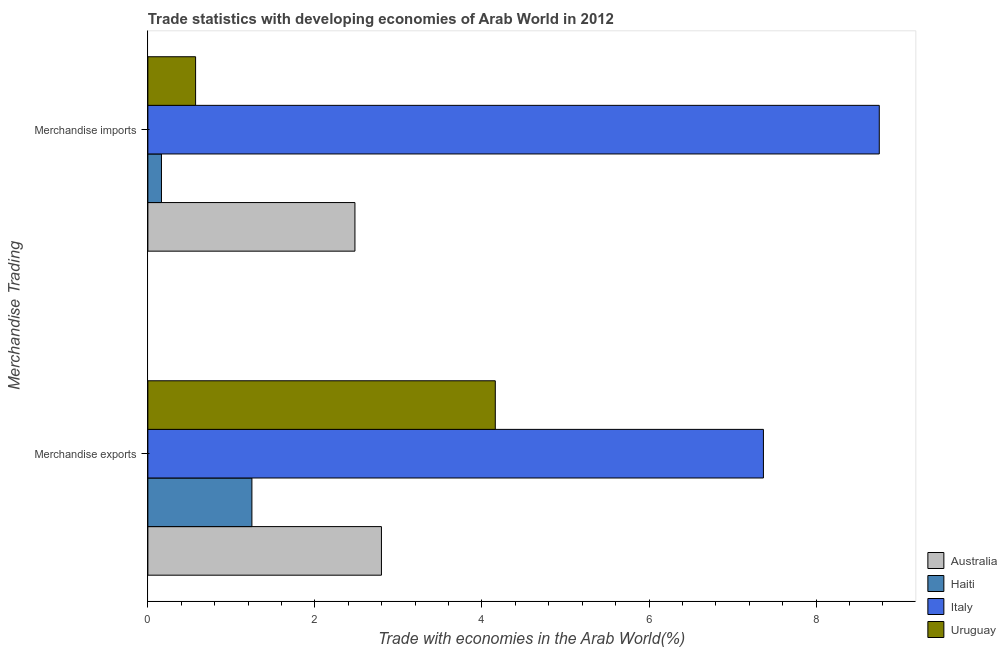How many groups of bars are there?
Keep it short and to the point. 2. Are the number of bars per tick equal to the number of legend labels?
Offer a very short reply. Yes. Are the number of bars on each tick of the Y-axis equal?
Offer a terse response. Yes. How many bars are there on the 1st tick from the bottom?
Provide a short and direct response. 4. What is the label of the 2nd group of bars from the top?
Your answer should be very brief. Merchandise exports. What is the merchandise imports in Italy?
Give a very brief answer. 8.76. Across all countries, what is the maximum merchandise exports?
Ensure brevity in your answer.  7.37. Across all countries, what is the minimum merchandise exports?
Offer a terse response. 1.25. In which country was the merchandise imports maximum?
Your response must be concise. Italy. In which country was the merchandise imports minimum?
Your response must be concise. Haiti. What is the total merchandise exports in the graph?
Offer a terse response. 15.57. What is the difference between the merchandise imports in Australia and that in Uruguay?
Provide a succinct answer. 1.91. What is the difference between the merchandise imports in Uruguay and the merchandise exports in Haiti?
Your answer should be very brief. -0.67. What is the average merchandise exports per country?
Provide a short and direct response. 3.89. What is the difference between the merchandise imports and merchandise exports in Uruguay?
Provide a succinct answer. -3.59. In how many countries, is the merchandise exports greater than 4 %?
Give a very brief answer. 2. What is the ratio of the merchandise imports in Uruguay to that in Italy?
Your answer should be very brief. 0.07. Are all the bars in the graph horizontal?
Offer a terse response. Yes. What is the difference between two consecutive major ticks on the X-axis?
Offer a terse response. 2. Does the graph contain grids?
Provide a succinct answer. No. Where does the legend appear in the graph?
Provide a short and direct response. Bottom right. How are the legend labels stacked?
Give a very brief answer. Vertical. What is the title of the graph?
Your response must be concise. Trade statistics with developing economies of Arab World in 2012. What is the label or title of the X-axis?
Your response must be concise. Trade with economies in the Arab World(%). What is the label or title of the Y-axis?
Your answer should be very brief. Merchandise Trading. What is the Trade with economies in the Arab World(%) in Australia in Merchandise exports?
Your answer should be compact. 2.8. What is the Trade with economies in the Arab World(%) in Haiti in Merchandise exports?
Offer a terse response. 1.25. What is the Trade with economies in the Arab World(%) of Italy in Merchandise exports?
Make the answer very short. 7.37. What is the Trade with economies in the Arab World(%) in Uruguay in Merchandise exports?
Offer a terse response. 4.16. What is the Trade with economies in the Arab World(%) in Australia in Merchandise imports?
Your answer should be compact. 2.48. What is the Trade with economies in the Arab World(%) in Haiti in Merchandise imports?
Offer a very short reply. 0.16. What is the Trade with economies in the Arab World(%) in Italy in Merchandise imports?
Offer a terse response. 8.76. What is the Trade with economies in the Arab World(%) of Uruguay in Merchandise imports?
Your answer should be very brief. 0.57. Across all Merchandise Trading, what is the maximum Trade with economies in the Arab World(%) of Australia?
Ensure brevity in your answer.  2.8. Across all Merchandise Trading, what is the maximum Trade with economies in the Arab World(%) of Haiti?
Make the answer very short. 1.25. Across all Merchandise Trading, what is the maximum Trade with economies in the Arab World(%) in Italy?
Your answer should be very brief. 8.76. Across all Merchandise Trading, what is the maximum Trade with economies in the Arab World(%) in Uruguay?
Your response must be concise. 4.16. Across all Merchandise Trading, what is the minimum Trade with economies in the Arab World(%) in Australia?
Your answer should be compact. 2.48. Across all Merchandise Trading, what is the minimum Trade with economies in the Arab World(%) of Haiti?
Offer a terse response. 0.16. Across all Merchandise Trading, what is the minimum Trade with economies in the Arab World(%) of Italy?
Offer a terse response. 7.37. Across all Merchandise Trading, what is the minimum Trade with economies in the Arab World(%) of Uruguay?
Your answer should be very brief. 0.57. What is the total Trade with economies in the Arab World(%) in Australia in the graph?
Ensure brevity in your answer.  5.28. What is the total Trade with economies in the Arab World(%) in Haiti in the graph?
Your response must be concise. 1.41. What is the total Trade with economies in the Arab World(%) in Italy in the graph?
Provide a succinct answer. 16.13. What is the total Trade with economies in the Arab World(%) in Uruguay in the graph?
Give a very brief answer. 4.73. What is the difference between the Trade with economies in the Arab World(%) of Australia in Merchandise exports and that in Merchandise imports?
Provide a succinct answer. 0.32. What is the difference between the Trade with economies in the Arab World(%) in Haiti in Merchandise exports and that in Merchandise imports?
Make the answer very short. 1.08. What is the difference between the Trade with economies in the Arab World(%) in Italy in Merchandise exports and that in Merchandise imports?
Ensure brevity in your answer.  -1.39. What is the difference between the Trade with economies in the Arab World(%) in Uruguay in Merchandise exports and that in Merchandise imports?
Your response must be concise. 3.59. What is the difference between the Trade with economies in the Arab World(%) of Australia in Merchandise exports and the Trade with economies in the Arab World(%) of Haiti in Merchandise imports?
Provide a short and direct response. 2.63. What is the difference between the Trade with economies in the Arab World(%) in Australia in Merchandise exports and the Trade with economies in the Arab World(%) in Italy in Merchandise imports?
Offer a terse response. -5.96. What is the difference between the Trade with economies in the Arab World(%) in Australia in Merchandise exports and the Trade with economies in the Arab World(%) in Uruguay in Merchandise imports?
Your answer should be very brief. 2.22. What is the difference between the Trade with economies in the Arab World(%) in Haiti in Merchandise exports and the Trade with economies in the Arab World(%) in Italy in Merchandise imports?
Your answer should be compact. -7.51. What is the difference between the Trade with economies in the Arab World(%) of Haiti in Merchandise exports and the Trade with economies in the Arab World(%) of Uruguay in Merchandise imports?
Provide a short and direct response. 0.67. What is the difference between the Trade with economies in the Arab World(%) of Italy in Merchandise exports and the Trade with economies in the Arab World(%) of Uruguay in Merchandise imports?
Ensure brevity in your answer.  6.8. What is the average Trade with economies in the Arab World(%) in Australia per Merchandise Trading?
Provide a succinct answer. 2.64. What is the average Trade with economies in the Arab World(%) in Haiti per Merchandise Trading?
Provide a short and direct response. 0.7. What is the average Trade with economies in the Arab World(%) in Italy per Merchandise Trading?
Ensure brevity in your answer.  8.06. What is the average Trade with economies in the Arab World(%) of Uruguay per Merchandise Trading?
Give a very brief answer. 2.37. What is the difference between the Trade with economies in the Arab World(%) in Australia and Trade with economies in the Arab World(%) in Haiti in Merchandise exports?
Your answer should be compact. 1.55. What is the difference between the Trade with economies in the Arab World(%) in Australia and Trade with economies in the Arab World(%) in Italy in Merchandise exports?
Give a very brief answer. -4.57. What is the difference between the Trade with economies in the Arab World(%) of Australia and Trade with economies in the Arab World(%) of Uruguay in Merchandise exports?
Provide a succinct answer. -1.36. What is the difference between the Trade with economies in the Arab World(%) in Haiti and Trade with economies in the Arab World(%) in Italy in Merchandise exports?
Keep it short and to the point. -6.12. What is the difference between the Trade with economies in the Arab World(%) in Haiti and Trade with economies in the Arab World(%) in Uruguay in Merchandise exports?
Your answer should be very brief. -2.91. What is the difference between the Trade with economies in the Arab World(%) in Italy and Trade with economies in the Arab World(%) in Uruguay in Merchandise exports?
Offer a terse response. 3.21. What is the difference between the Trade with economies in the Arab World(%) of Australia and Trade with economies in the Arab World(%) of Haiti in Merchandise imports?
Offer a terse response. 2.32. What is the difference between the Trade with economies in the Arab World(%) of Australia and Trade with economies in the Arab World(%) of Italy in Merchandise imports?
Make the answer very short. -6.28. What is the difference between the Trade with economies in the Arab World(%) of Australia and Trade with economies in the Arab World(%) of Uruguay in Merchandise imports?
Your answer should be compact. 1.91. What is the difference between the Trade with economies in the Arab World(%) of Haiti and Trade with economies in the Arab World(%) of Italy in Merchandise imports?
Offer a very short reply. -8.59. What is the difference between the Trade with economies in the Arab World(%) in Haiti and Trade with economies in the Arab World(%) in Uruguay in Merchandise imports?
Your answer should be very brief. -0.41. What is the difference between the Trade with economies in the Arab World(%) in Italy and Trade with economies in the Arab World(%) in Uruguay in Merchandise imports?
Provide a succinct answer. 8.19. What is the ratio of the Trade with economies in the Arab World(%) of Australia in Merchandise exports to that in Merchandise imports?
Your answer should be compact. 1.13. What is the ratio of the Trade with economies in the Arab World(%) in Haiti in Merchandise exports to that in Merchandise imports?
Offer a terse response. 7.65. What is the ratio of the Trade with economies in the Arab World(%) in Italy in Merchandise exports to that in Merchandise imports?
Ensure brevity in your answer.  0.84. What is the ratio of the Trade with economies in the Arab World(%) in Uruguay in Merchandise exports to that in Merchandise imports?
Make the answer very short. 7.28. What is the difference between the highest and the second highest Trade with economies in the Arab World(%) in Australia?
Ensure brevity in your answer.  0.32. What is the difference between the highest and the second highest Trade with economies in the Arab World(%) in Haiti?
Provide a succinct answer. 1.08. What is the difference between the highest and the second highest Trade with economies in the Arab World(%) of Italy?
Offer a very short reply. 1.39. What is the difference between the highest and the second highest Trade with economies in the Arab World(%) of Uruguay?
Offer a very short reply. 3.59. What is the difference between the highest and the lowest Trade with economies in the Arab World(%) in Australia?
Your response must be concise. 0.32. What is the difference between the highest and the lowest Trade with economies in the Arab World(%) of Haiti?
Offer a terse response. 1.08. What is the difference between the highest and the lowest Trade with economies in the Arab World(%) of Italy?
Make the answer very short. 1.39. What is the difference between the highest and the lowest Trade with economies in the Arab World(%) in Uruguay?
Offer a very short reply. 3.59. 